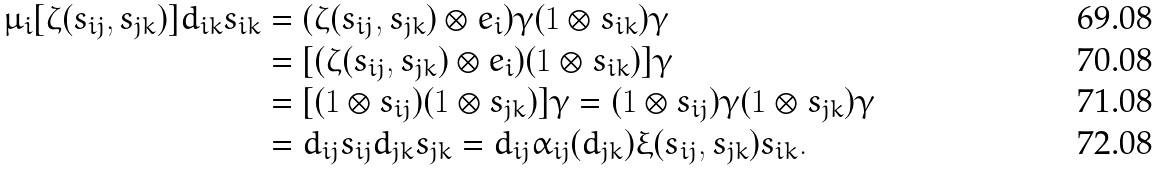Convert formula to latex. <formula><loc_0><loc_0><loc_500><loc_500>\mu _ { i } [ \zeta ( s _ { i j } , s _ { j k } ) ] d _ { i k } s _ { i k } & = ( \zeta ( s _ { i j } , s _ { j k } ) \otimes e _ { i } ) \gamma ( 1 \otimes s _ { i k } ) \gamma \\ & = [ ( \zeta ( s _ { i j } , s _ { j k } ) \otimes e _ { i } ) ( 1 \otimes s _ { i k } ) ] \gamma \\ & = [ ( 1 \otimes s _ { i j } ) ( 1 \otimes s _ { j k } ) ] \gamma = ( 1 \otimes s _ { i j } ) \gamma ( 1 \otimes s _ { j k } ) \gamma \\ & = d _ { i j } s _ { i j } d _ { j k } s _ { j k } = d _ { i j } \alpha _ { i j } ( d _ { j k } ) \xi ( s _ { i j } , s _ { j k } ) s _ { i k } .</formula> 